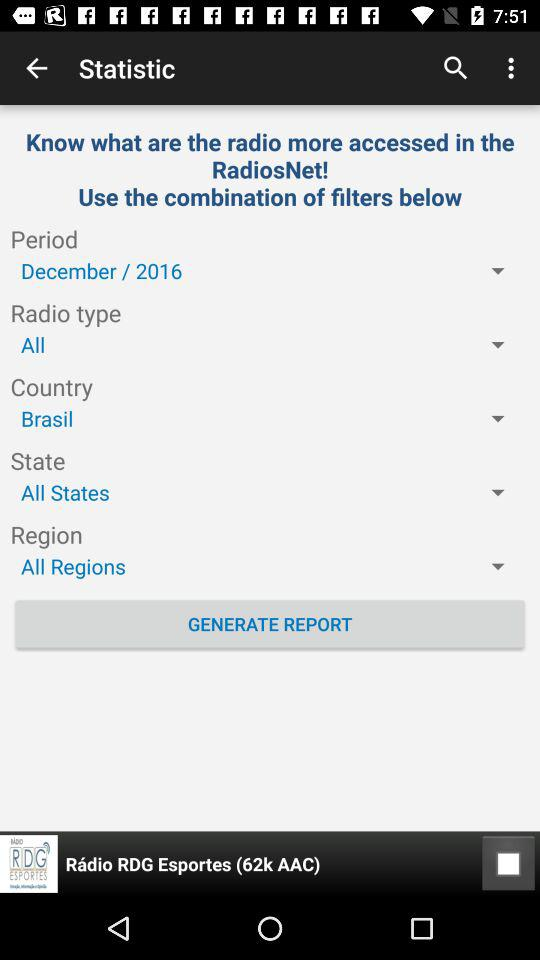What year is displayed? The displayed year is 2016. 